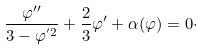<formula> <loc_0><loc_0><loc_500><loc_500>\frac { \varphi ^ { \prime \prime } } { 3 - \varphi ^ { ^ { \prime } 2 } } + \frac { 2 } { 3 } \varphi ^ { \prime } + \alpha ( \varphi ) = 0 \cdot</formula> 